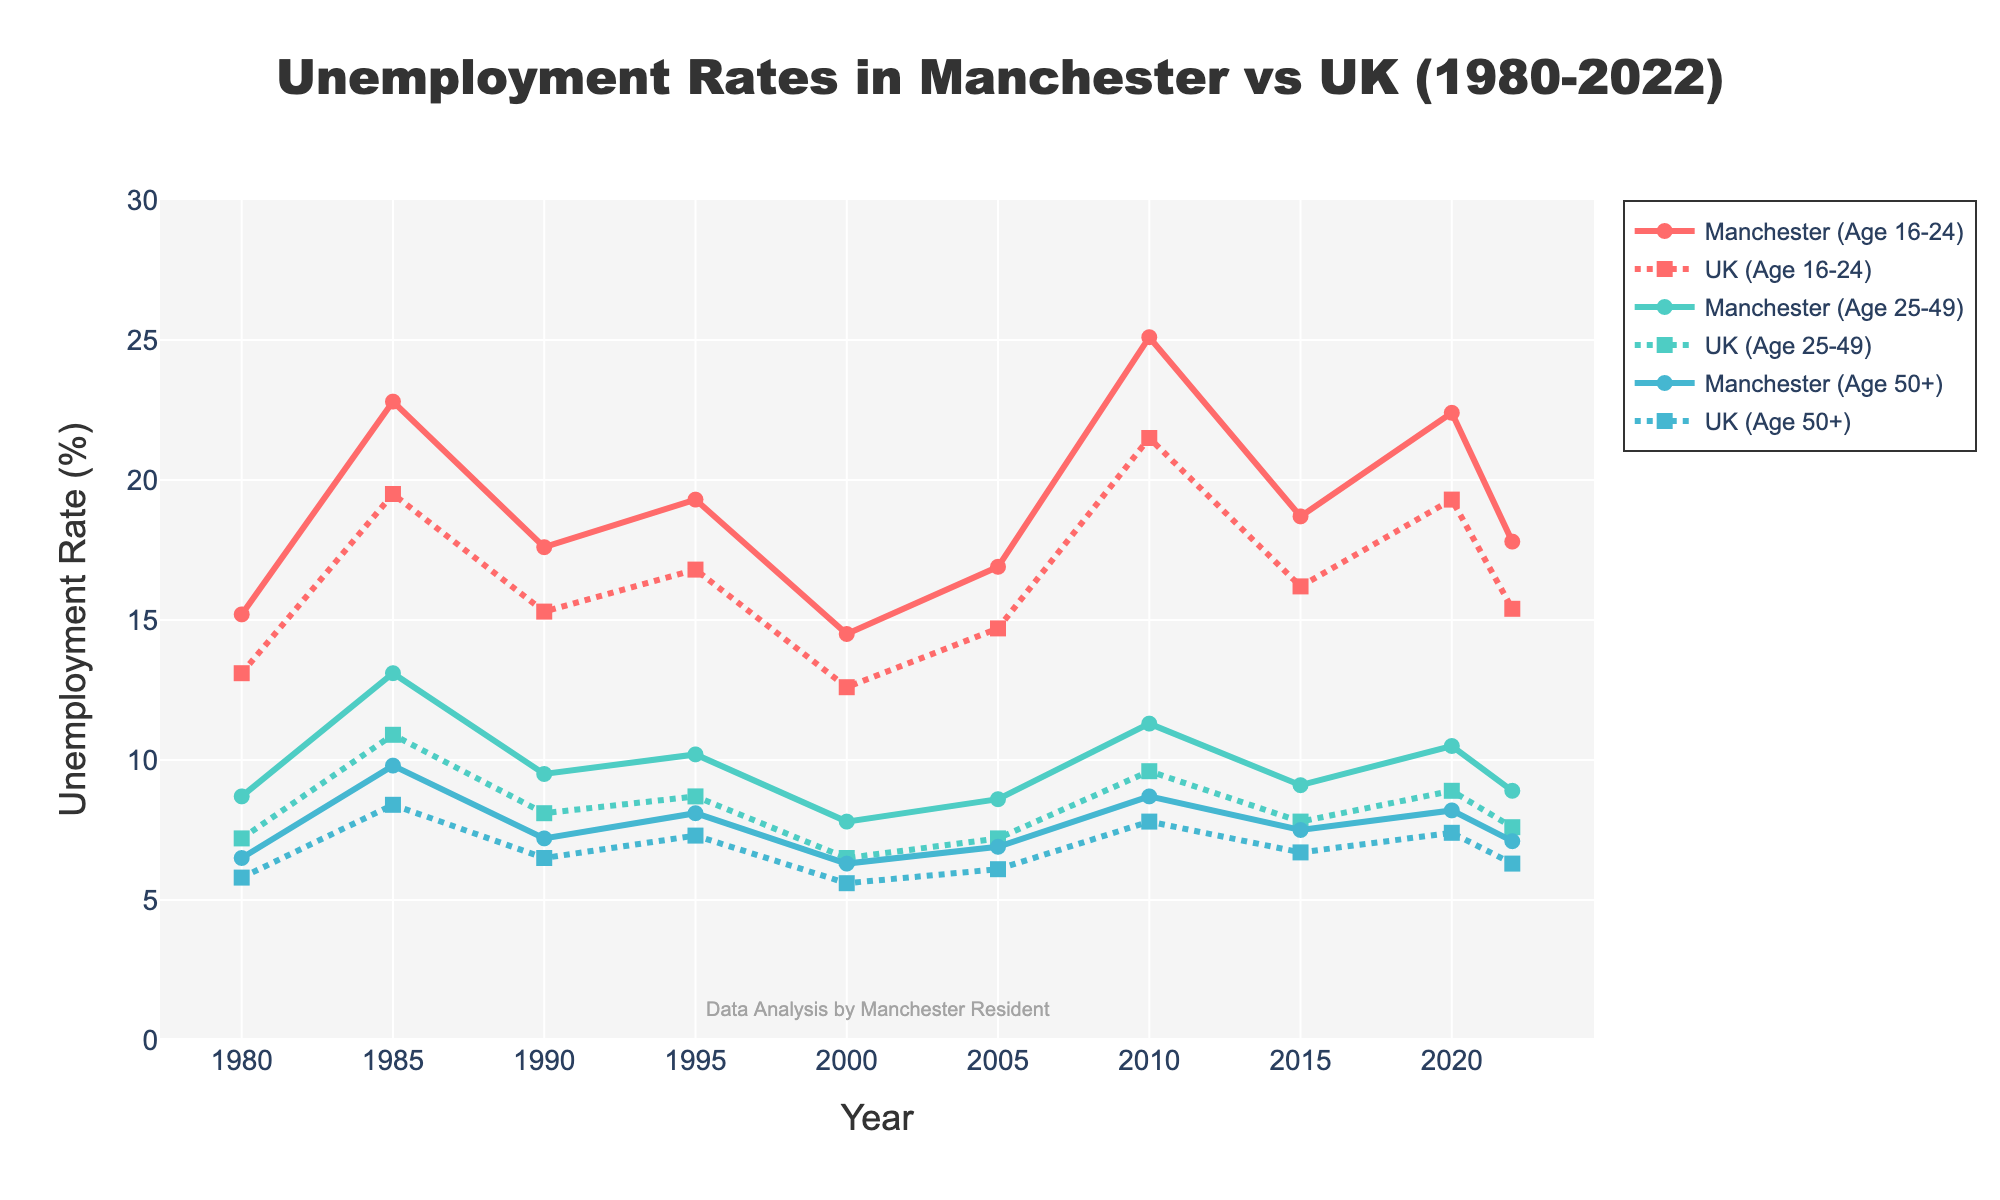What's the highest unemployment rate for the age group 16-24 in Manchester? To find the highest unemployment rate for the age group 16-24 in Manchester, look at the "Age 16-24 Manchester" line on the graph and identify the peak point. This peak occurs in 2010.
Answer: 25.1% What's the difference between the unemployment rate of 16-24-year-olds in Manchester and the UK in 1985? To find the difference, look at the 1985 data points for the age group 16-24. Manchester's rate is 22.8% and the UK's rate is 19.5%. Subtract the UK's rate from Manchester's rate: 22.8 - 19.5 = 3.3.
Answer: 3.3% What trend do you notice in the unemployment rate of the age group 50+ in Manchester from 1980 to 2022? The "Age 50+ Manchester" line shows a gradually decreasing trend from the high point in 1985 to a lower point in 2022. Although there are small increases in certain years, the overall trend is downward.
Answer: Downward trend Which age group had the lowest unemployment rate in the UK in 2000? To find the age group with the lowest unemployment rate in the UK in 2000, compare the data points for each age group in that year. "Age 50+ UK" has the lowest rate in 2000.
Answer: Age 50+ What's the average unemployment rate for the age group 25-49 in Manchester over the specified years? Add all the unemployment rates for the age group 25-49 in Manchester from 1980 to 2022 and divide by the number of data points. (8.7 + 13.1 + 9.5 + 10.2 + 7.8 + 8.6 + 11.3 + 9.1 + 10.5 + 8.9) / 10 = 9.77.
Answer: 9.77% How did the unemployment rate for the age group 16-24 in Manchester change from 2010 to 2022? Look at the data points for the age group 16-24 in Manchester in 2010 and 2022. In 2010, it's 25.1%, and in 2022, it's 17.8%. Subtract the 2022 rate from the 2010 rate: 25.1 - 17.8 = 7.3.
Answer: Decreased by 7.3% Which age group experienced the largest increase in unemployment rate in Manchester from 1980 to 1985? Calculate the increase for each age group in Manchester by subtracting the 1980 rate from the 1985 rate: 
- Age 16-24: (22.8 - 15.2) = 7.6
- Age 25-49: (13.1 - 8.7) = 4.4
- Age 50+: (9.8 - 6.5) = 3.3
The largest increase is for the age group 16-24, which is 7.6.
Answer: Age 16-24 